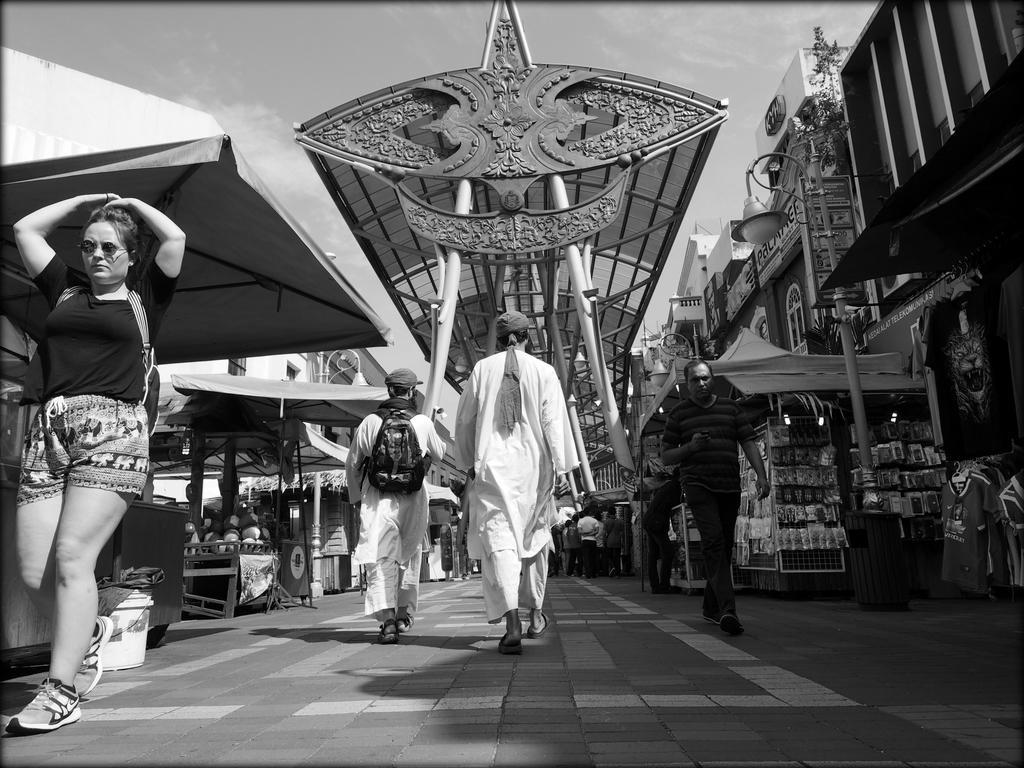Could you give a brief overview of what you see in this image? In this image we can see few persons. Behind the persons we can see few stalls and buildings. At the top we can see the sky and a metal roof. 